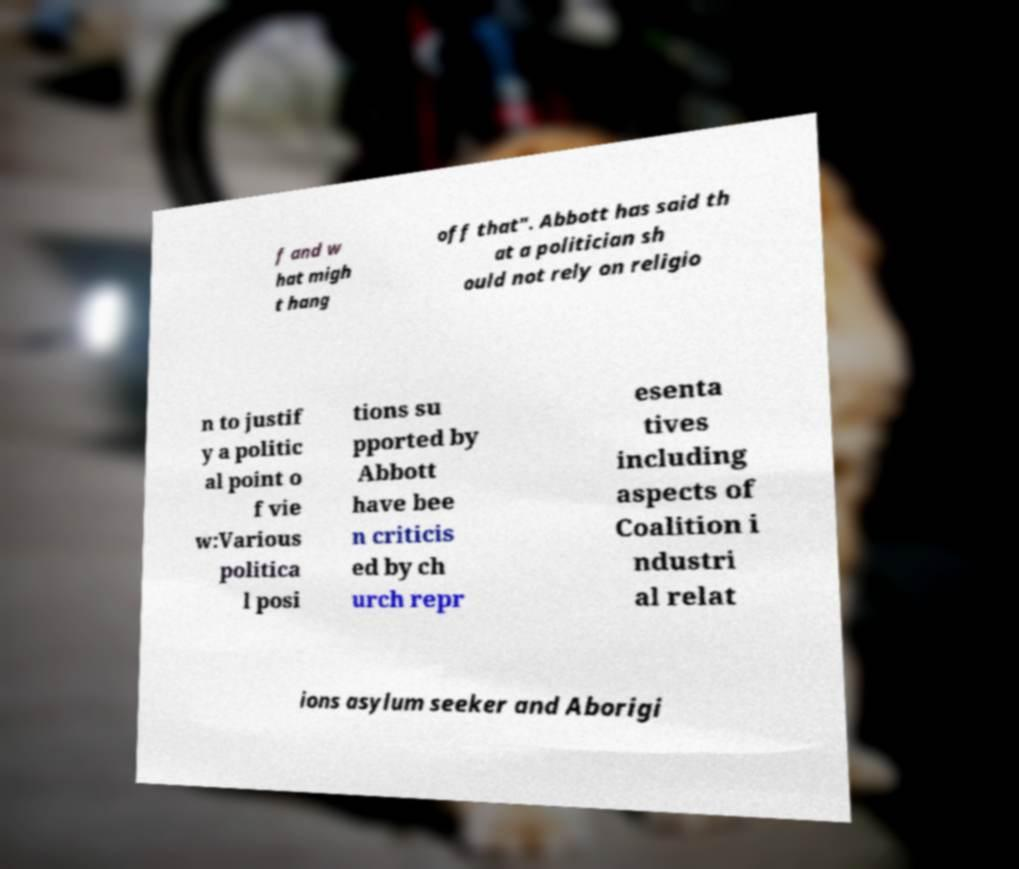What messages or text are displayed in this image? I need them in a readable, typed format. f and w hat migh t hang off that". Abbott has said th at a politician sh ould not rely on religio n to justif y a politic al point o f vie w:Various politica l posi tions su pported by Abbott have bee n criticis ed by ch urch repr esenta tives including aspects of Coalition i ndustri al relat ions asylum seeker and Aborigi 